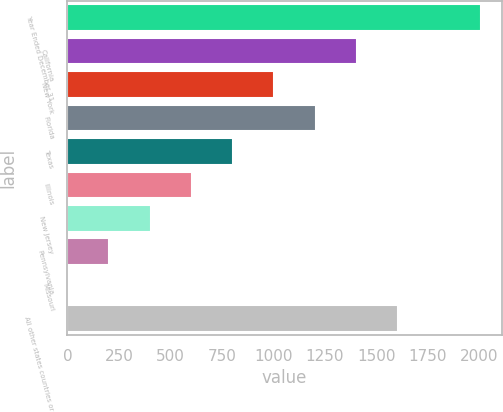Convert chart. <chart><loc_0><loc_0><loc_500><loc_500><bar_chart><fcel>Year Ended December 31<fcel>California<fcel>New York<fcel>Florida<fcel>Texas<fcel>Illinois<fcel>New Jersey<fcel>Pennsylvania<fcel>Missouri<fcel>All other states countries or<nl><fcel>2007<fcel>1405.77<fcel>1004.95<fcel>1205.36<fcel>804.54<fcel>604.13<fcel>403.72<fcel>203.31<fcel>2.9<fcel>1606.18<nl></chart> 